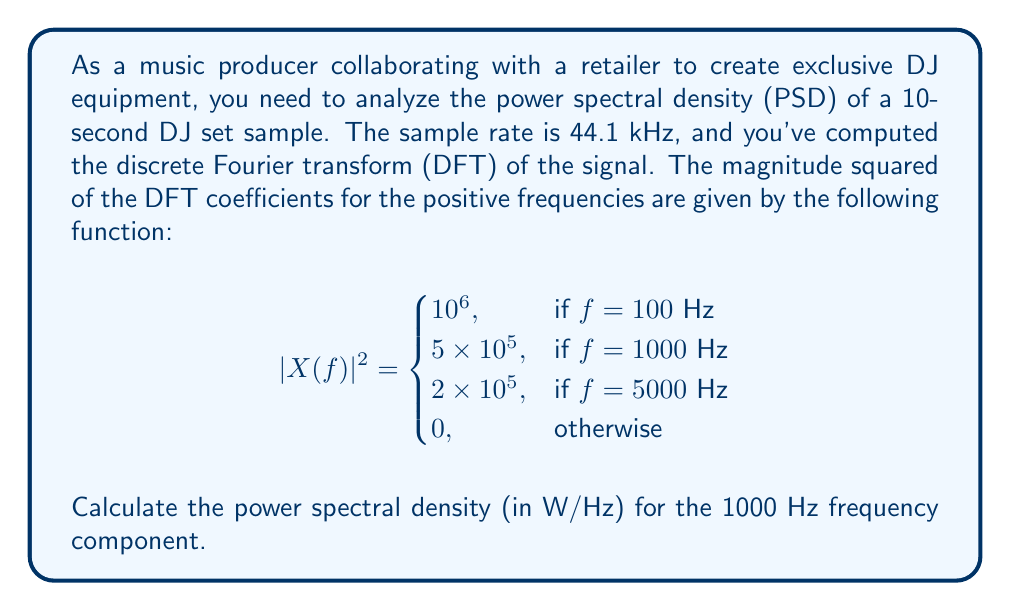Solve this math problem. To calculate the power spectral density (PSD) from the given discrete Fourier transform (DFT) data, we need to follow these steps:

1) Recall the relation between PSD and DFT for a discrete-time signal:

   $$S_{xx}(f) = \frac{1}{f_sN}|X(f)|^2$$

   Where:
   - $S_{xx}(f)$ is the PSD
   - $f_s$ is the sampling frequency
   - $N$ is the number of samples
   - $|X(f)|^2$ is the magnitude squared of the DFT

2) Given information:
   - Sampling rate $f_s = 44.1$ kHz = 44100 Hz
   - Duration of sample = 10 seconds
   - $|X(f)|^2 = 5 \times 10^5$ at $f = 1000$ Hz

3) Calculate the number of samples $N$:
   $N = f_s \times \text{duration} = 44100 \times 10 = 441000$ samples

4) Now, we can substitute these values into the PSD formula:

   $$S_{xx}(1000\text{ Hz}) = \frac{1}{44100 \times 441000} \times 5 \times 10^5$$

5) Simplify:
   $$S_{xx}(1000\text{ Hz}) = \frac{5 \times 10^5}{1.94481 \times 10^{10}} \approx 2.5709 \times 10^{-5} \text{ W/Hz}$$

Therefore, the power spectral density at 1000 Hz is approximately $2.5709 \times 10^{-5}$ W/Hz.
Answer: $2.5709 \times 10^{-5}$ W/Hz 